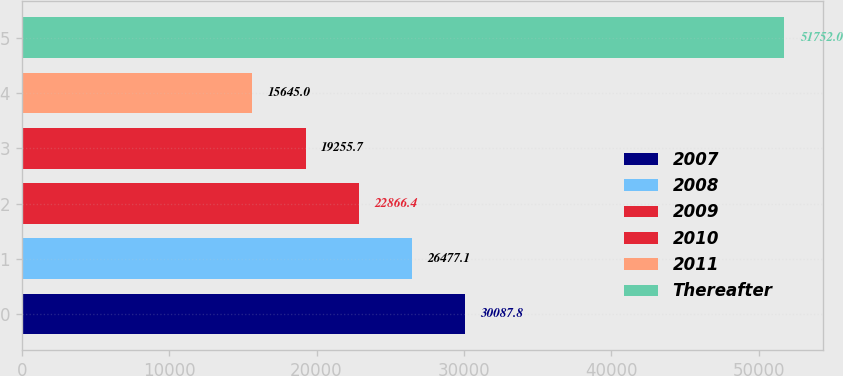Convert chart. <chart><loc_0><loc_0><loc_500><loc_500><bar_chart><fcel>2007<fcel>2008<fcel>2009<fcel>2010<fcel>2011<fcel>Thereafter<nl><fcel>30087.8<fcel>26477.1<fcel>22866.4<fcel>19255.7<fcel>15645<fcel>51752<nl></chart> 